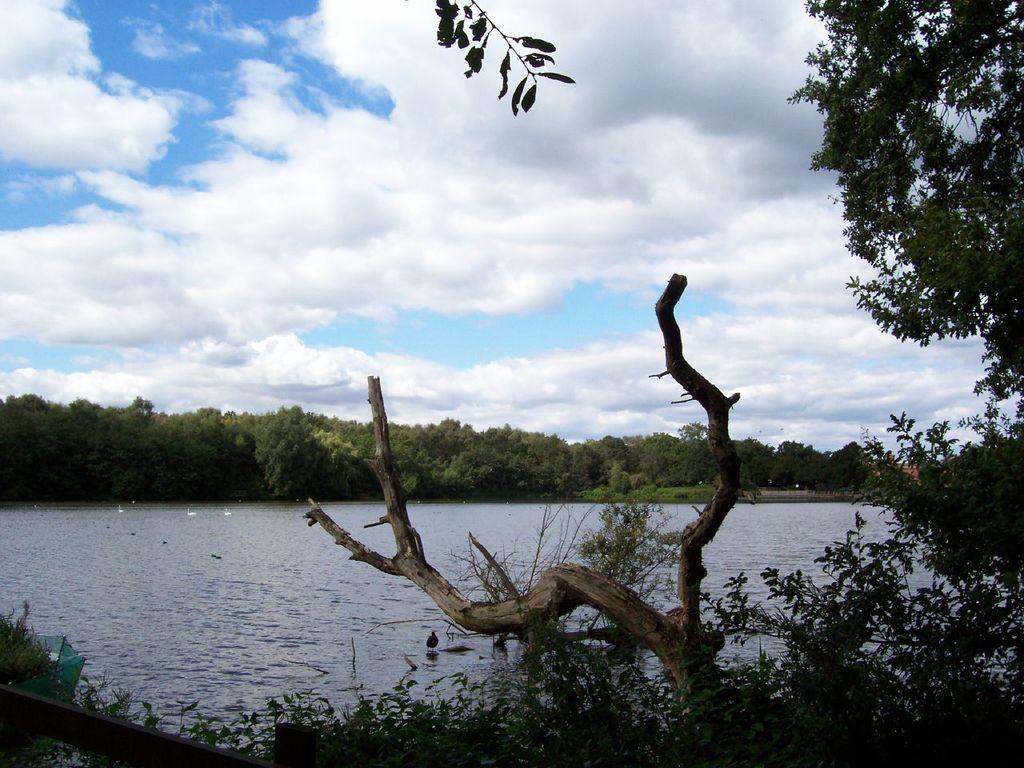What type of vegetation can be seen in the image? There are trees and plants in the image. What structure is present in the image? There is a fence in the image. What animals can be seen in the image? There are flocks of birds in the water. What part of the natural environment is visible in the image? The sky is visible in the background of the image. What might be the location of the image? The image may have been taken near a lake. What type of berry is growing on the fence in the image? There are no berries mentioned or visible in the image; the focus is on trees, plants, birds, and the fence. How much does the jar weigh in the image? There is no jar present in the image, so its weight cannot be determined. 